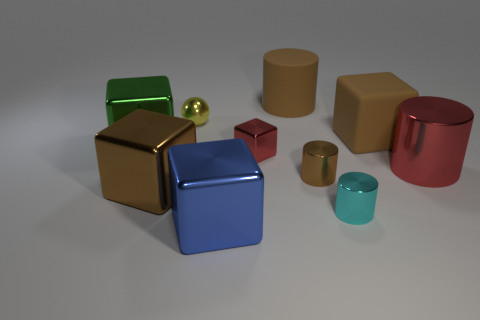What shape is the big rubber object that is the same color as the rubber cylinder?
Keep it short and to the point. Cube. What size is the metal cylinder that is the same color as the tiny shiny block?
Make the answer very short. Large. Are there any tiny yellow metallic things in front of the red thing that is on the right side of the brown cylinder that is on the right side of the rubber cylinder?
Ensure brevity in your answer.  No. Are there more red blocks than small things?
Provide a short and direct response. No. What is the color of the large cylinder on the left side of the large red metal thing?
Offer a very short reply. Brown. Are there more matte cylinders on the left side of the big green thing than gray blocks?
Provide a short and direct response. No. Is the material of the tiny brown cylinder the same as the big blue thing?
Offer a terse response. Yes. How many other things are there of the same shape as the big blue metallic object?
Offer a very short reply. 4. Is there any other thing that has the same material as the cyan cylinder?
Provide a succinct answer. Yes. What is the color of the big metal block behind the brown metallic object that is left of the large cylinder that is behind the metallic sphere?
Ensure brevity in your answer.  Green. 